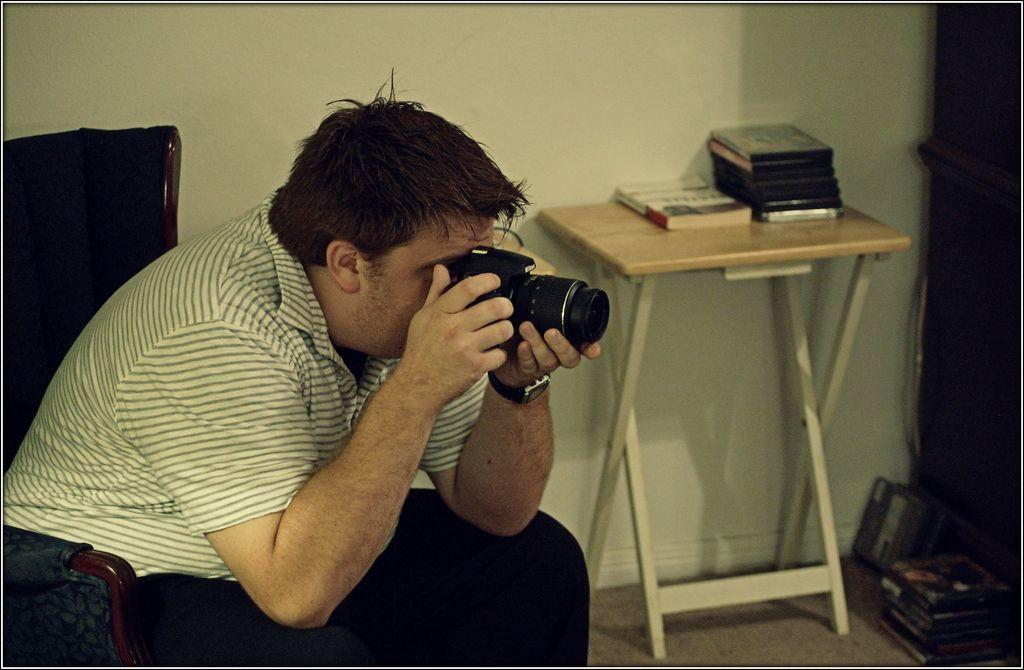What is the person in the image doing? The person is sitting on a chair in the image. What is the person wearing? The person is wearing a white dress. What is the person holding in their hands? The person is holding a camera in their hands. Where is the camera located in the image? The camera is on the right side of the image. What else can be seen in the image besides the person and the camera? There are books on a table in the image. What type of toy is the person playing with on the sidewalk in the image? There is no toy or sidewalk present in the image; it features a person sitting on a chair, wearing a white dress, and holding a camera. 